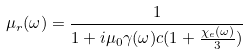<formula> <loc_0><loc_0><loc_500><loc_500>\mu _ { r } ( \omega ) = \frac { 1 } { 1 + i \mu _ { 0 } \gamma ( \omega ) c ( 1 + \frac { \chi _ { e } ( \omega ) } { 3 } ) }</formula> 